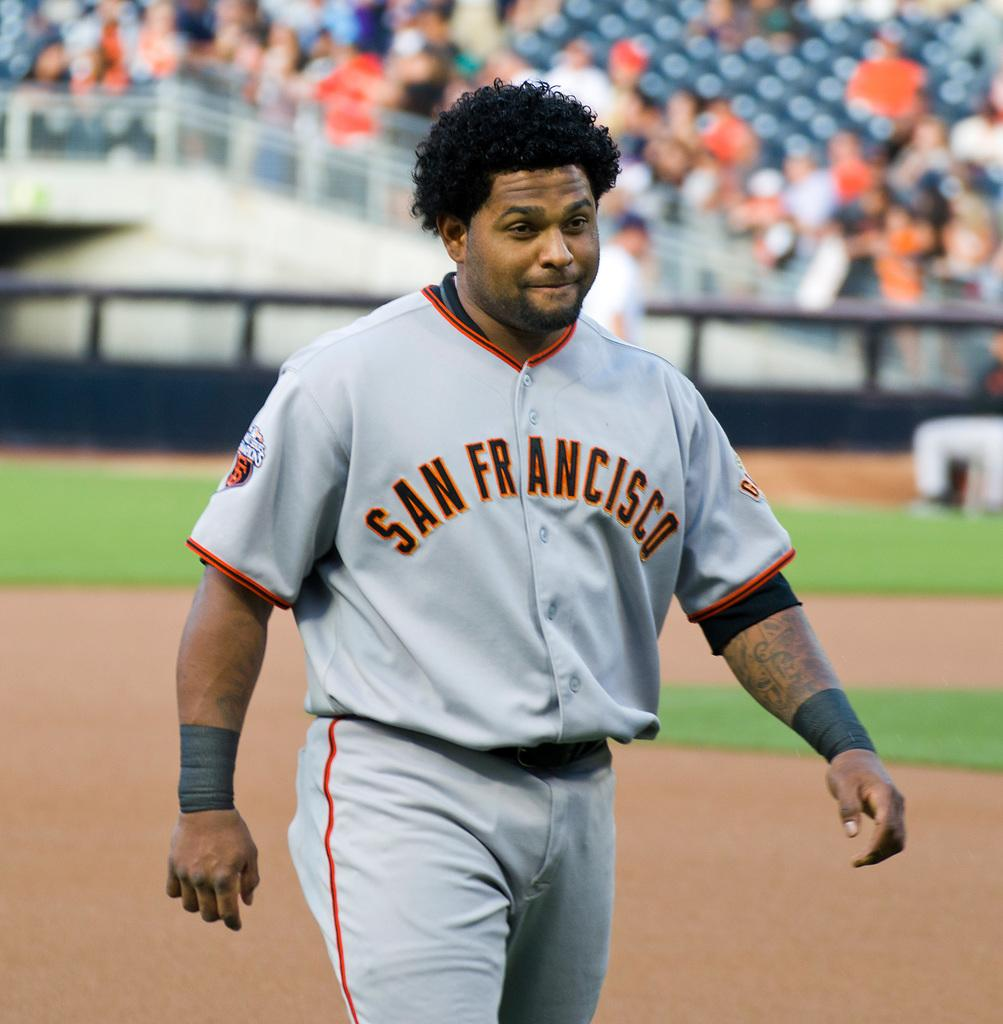<image>
Provide a brief description of the given image. A baseball player with a red and gray uniform has the san francisco logo on his chest. 